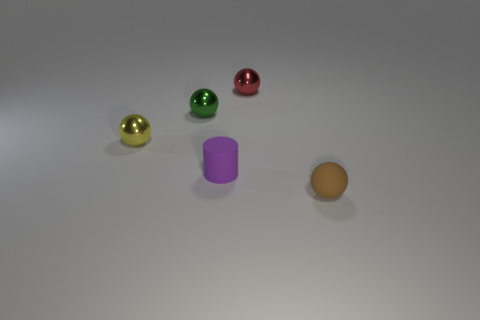Do the small red metallic object and the rubber thing that is on the right side of the red object have the same shape?
Your response must be concise. Yes. How many objects are either tiny matte objects behind the small matte sphere or tiny balls that are to the right of the small green thing?
Provide a short and direct response. 3. What shape is the thing in front of the tiny purple object?
Give a very brief answer. Sphere. There is a metal object to the right of the small matte cylinder; is its shape the same as the tiny green object?
Provide a succinct answer. Yes. How many objects are metal balls that are on the right side of the tiny yellow shiny object or cyan metal cylinders?
Provide a short and direct response. 2. There is another tiny rubber object that is the same shape as the yellow thing; what is its color?
Offer a very short reply. Brown. How big is the shiny thing that is in front of the tiny green shiny thing?
Your answer should be very brief. Small. What number of other objects are the same material as the brown object?
Your answer should be compact. 1. Is the number of brown spheres greater than the number of small red cylinders?
Provide a succinct answer. Yes. What color is the cylinder?
Keep it short and to the point. Purple. 